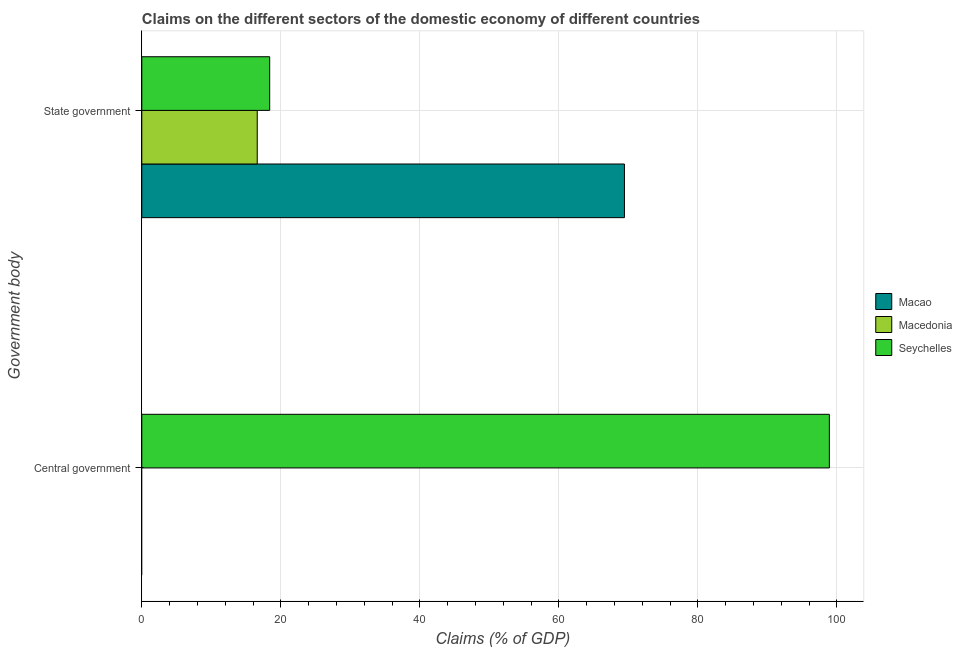Are the number of bars on each tick of the Y-axis equal?
Give a very brief answer. No. What is the label of the 1st group of bars from the top?
Give a very brief answer. State government. What is the claims on central government in Macedonia?
Provide a succinct answer. 0. Across all countries, what is the maximum claims on central government?
Ensure brevity in your answer.  98.92. Across all countries, what is the minimum claims on central government?
Offer a very short reply. 0. In which country was the claims on central government maximum?
Offer a terse response. Seychelles. What is the total claims on state government in the graph?
Your answer should be compact. 104.44. What is the difference between the claims on state government in Macedonia and that in Seychelles?
Offer a terse response. -1.79. What is the difference between the claims on central government in Macao and the claims on state government in Macedonia?
Your answer should be very brief. -16.61. What is the average claims on state government per country?
Provide a short and direct response. 34.81. What is the difference between the claims on state government and claims on central government in Seychelles?
Ensure brevity in your answer.  -80.52. What is the ratio of the claims on state government in Seychelles to that in Macao?
Give a very brief answer. 0.26. Is the claims on state government in Macedonia less than that in Seychelles?
Your answer should be very brief. Yes. How many bars are there?
Give a very brief answer. 4. What is the difference between two consecutive major ticks on the X-axis?
Provide a succinct answer. 20. Does the graph contain any zero values?
Keep it short and to the point. Yes. Where does the legend appear in the graph?
Provide a short and direct response. Center right. What is the title of the graph?
Keep it short and to the point. Claims on the different sectors of the domestic economy of different countries. What is the label or title of the X-axis?
Offer a very short reply. Claims (% of GDP). What is the label or title of the Y-axis?
Your answer should be very brief. Government body. What is the Claims (% of GDP) of Macao in Central government?
Your response must be concise. 0. What is the Claims (% of GDP) in Seychelles in Central government?
Make the answer very short. 98.92. What is the Claims (% of GDP) in Macao in State government?
Provide a succinct answer. 69.43. What is the Claims (% of GDP) in Macedonia in State government?
Offer a very short reply. 16.61. What is the Claims (% of GDP) in Seychelles in State government?
Offer a terse response. 18.4. Across all Government body, what is the maximum Claims (% of GDP) in Macao?
Your response must be concise. 69.43. Across all Government body, what is the maximum Claims (% of GDP) in Macedonia?
Your answer should be very brief. 16.61. Across all Government body, what is the maximum Claims (% of GDP) in Seychelles?
Ensure brevity in your answer.  98.92. Across all Government body, what is the minimum Claims (% of GDP) of Seychelles?
Provide a succinct answer. 18.4. What is the total Claims (% of GDP) of Macao in the graph?
Your answer should be compact. 69.43. What is the total Claims (% of GDP) of Macedonia in the graph?
Give a very brief answer. 16.61. What is the total Claims (% of GDP) of Seychelles in the graph?
Your response must be concise. 117.31. What is the difference between the Claims (% of GDP) of Seychelles in Central government and that in State government?
Make the answer very short. 80.52. What is the average Claims (% of GDP) of Macao per Government body?
Keep it short and to the point. 34.72. What is the average Claims (% of GDP) in Macedonia per Government body?
Give a very brief answer. 8.3. What is the average Claims (% of GDP) in Seychelles per Government body?
Your answer should be compact. 58.66. What is the difference between the Claims (% of GDP) in Macao and Claims (% of GDP) in Macedonia in State government?
Keep it short and to the point. 52.83. What is the difference between the Claims (% of GDP) of Macao and Claims (% of GDP) of Seychelles in State government?
Your response must be concise. 51.04. What is the difference between the Claims (% of GDP) of Macedonia and Claims (% of GDP) of Seychelles in State government?
Your answer should be very brief. -1.79. What is the ratio of the Claims (% of GDP) in Seychelles in Central government to that in State government?
Keep it short and to the point. 5.38. What is the difference between the highest and the second highest Claims (% of GDP) of Seychelles?
Your answer should be very brief. 80.52. What is the difference between the highest and the lowest Claims (% of GDP) in Macao?
Your answer should be very brief. 69.43. What is the difference between the highest and the lowest Claims (% of GDP) of Macedonia?
Keep it short and to the point. 16.61. What is the difference between the highest and the lowest Claims (% of GDP) in Seychelles?
Offer a terse response. 80.52. 